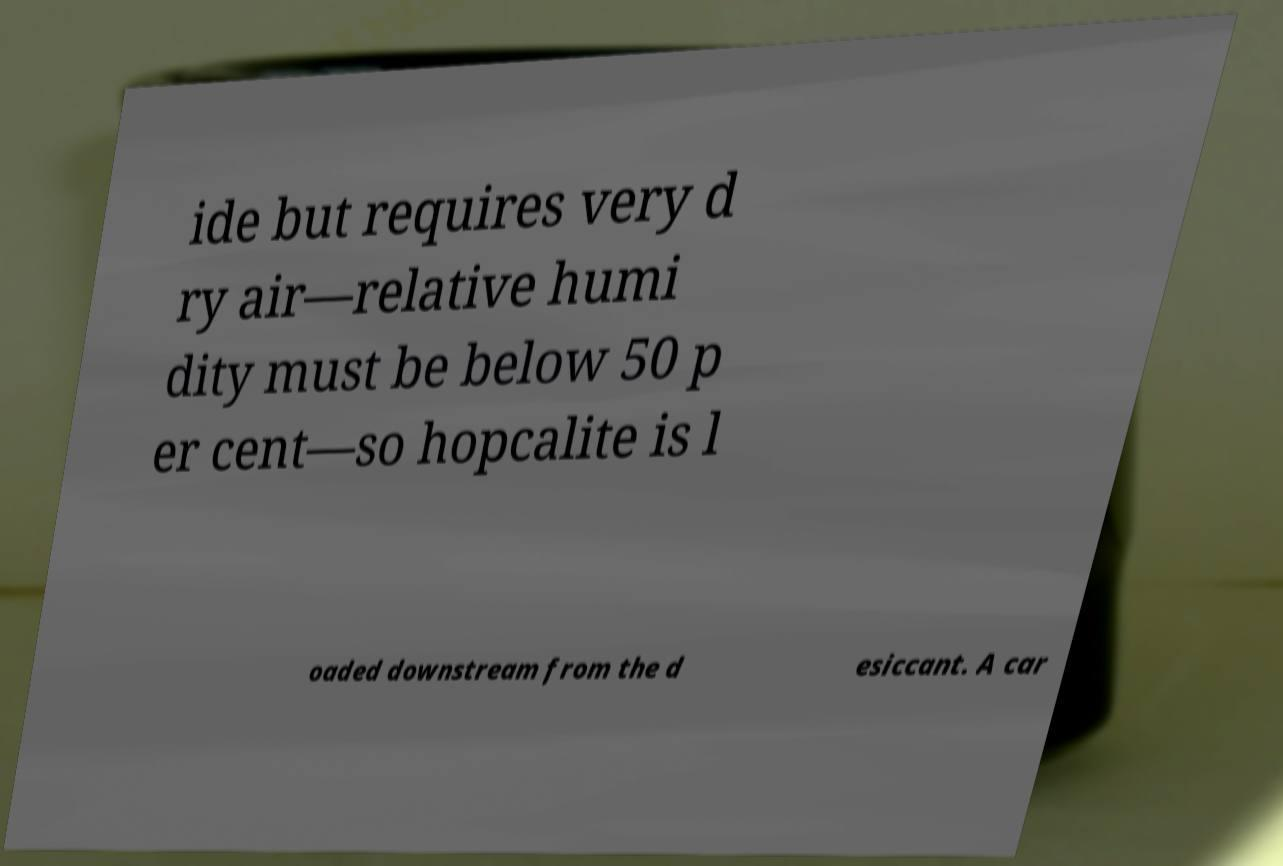For documentation purposes, I need the text within this image transcribed. Could you provide that? ide but requires very d ry air—relative humi dity must be below 50 p er cent—so hopcalite is l oaded downstream from the d esiccant. A car 